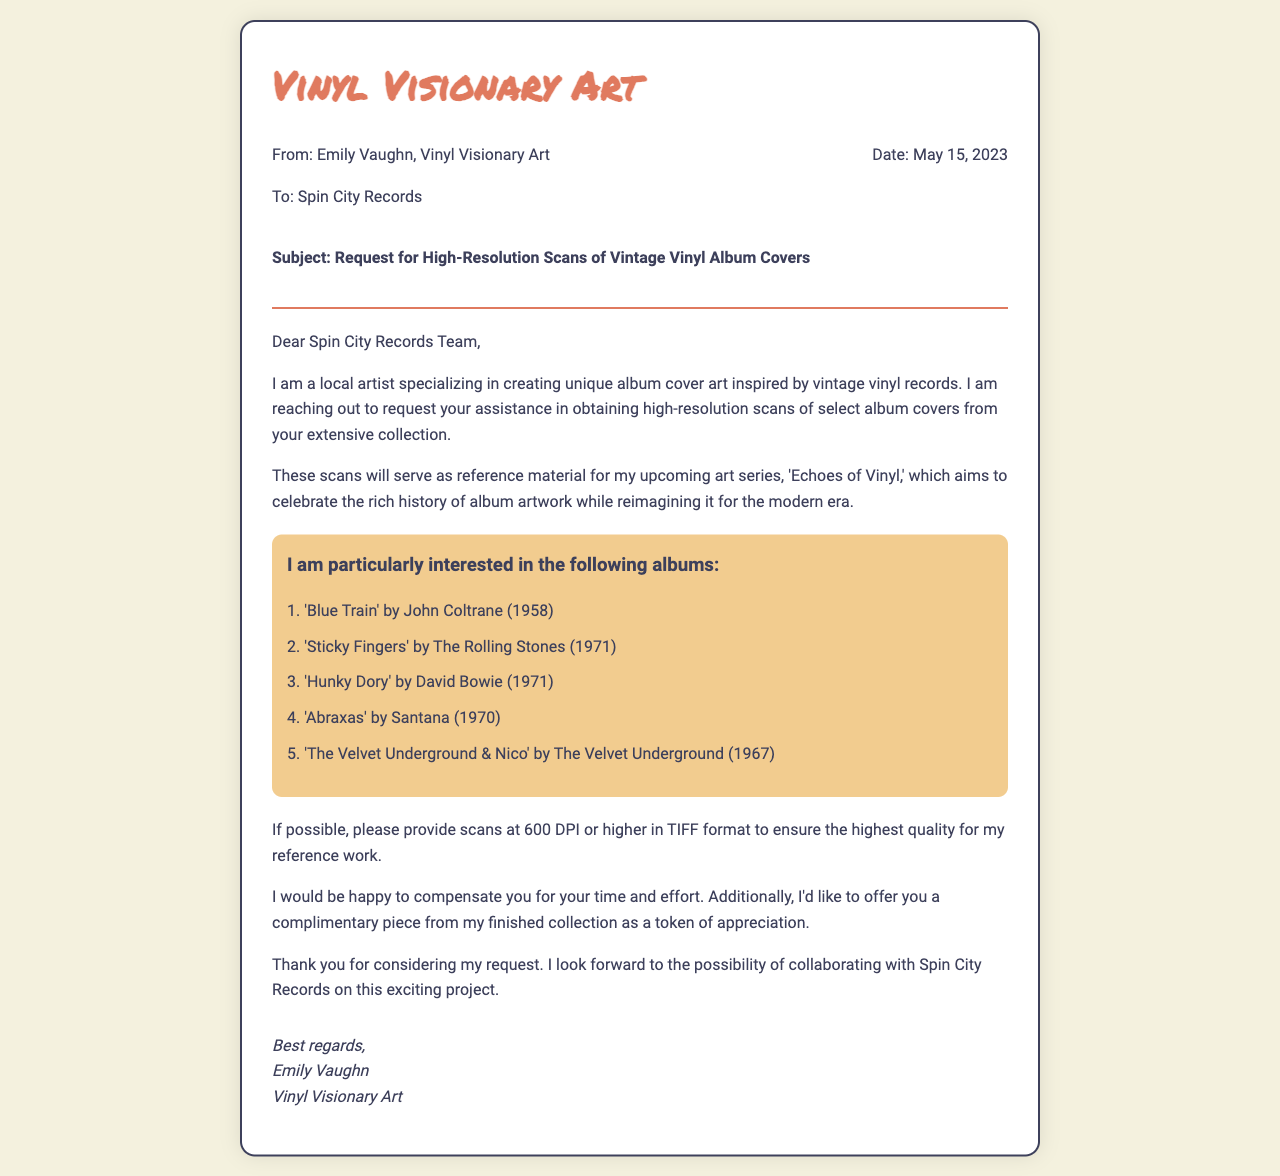What is the name of the sender? The sender's name is listed in the document as "Emily Vaughn".
Answer: Emily Vaughn What is the date of the fax? The date is explicitly mentioned in the header of the document as "May 15, 2023".
Answer: May 15, 2023 What is the main subject of the fax? The subject line clearly states the primary intention of the fax, which is a request for high-resolution scans.
Answer: Request for High-Resolution Scans of Vintage Vinyl Album Covers How many albums does the sender request scans for? The document lists a specific number of albums in the album list section.
Answer: Five What format does the sender request the scans in? The document specifies the desired file format for the scans needed for reference work.
Answer: TIFF What is the title of the upcoming art series mentioned? The sender outlines a specific project involving album artwork, clearly naming the series.
Answer: Echoes of Vinyl What is the compensation offered to Spin City Records? The sender mentions a specific form of compensation in exchange for the scans of the albums.
Answer: Complimentary piece from the finished collection Who is the recipient of the fax? The recipient is stated in the initial section of the header, indicating to whom the fax is addressed.
Answer: Spin City Records What resolution (DPI) does the sender request for the scans? The document specifies a particular scanning quality that the sender requests for the album covers.
Answer: 600 DPI or higher 